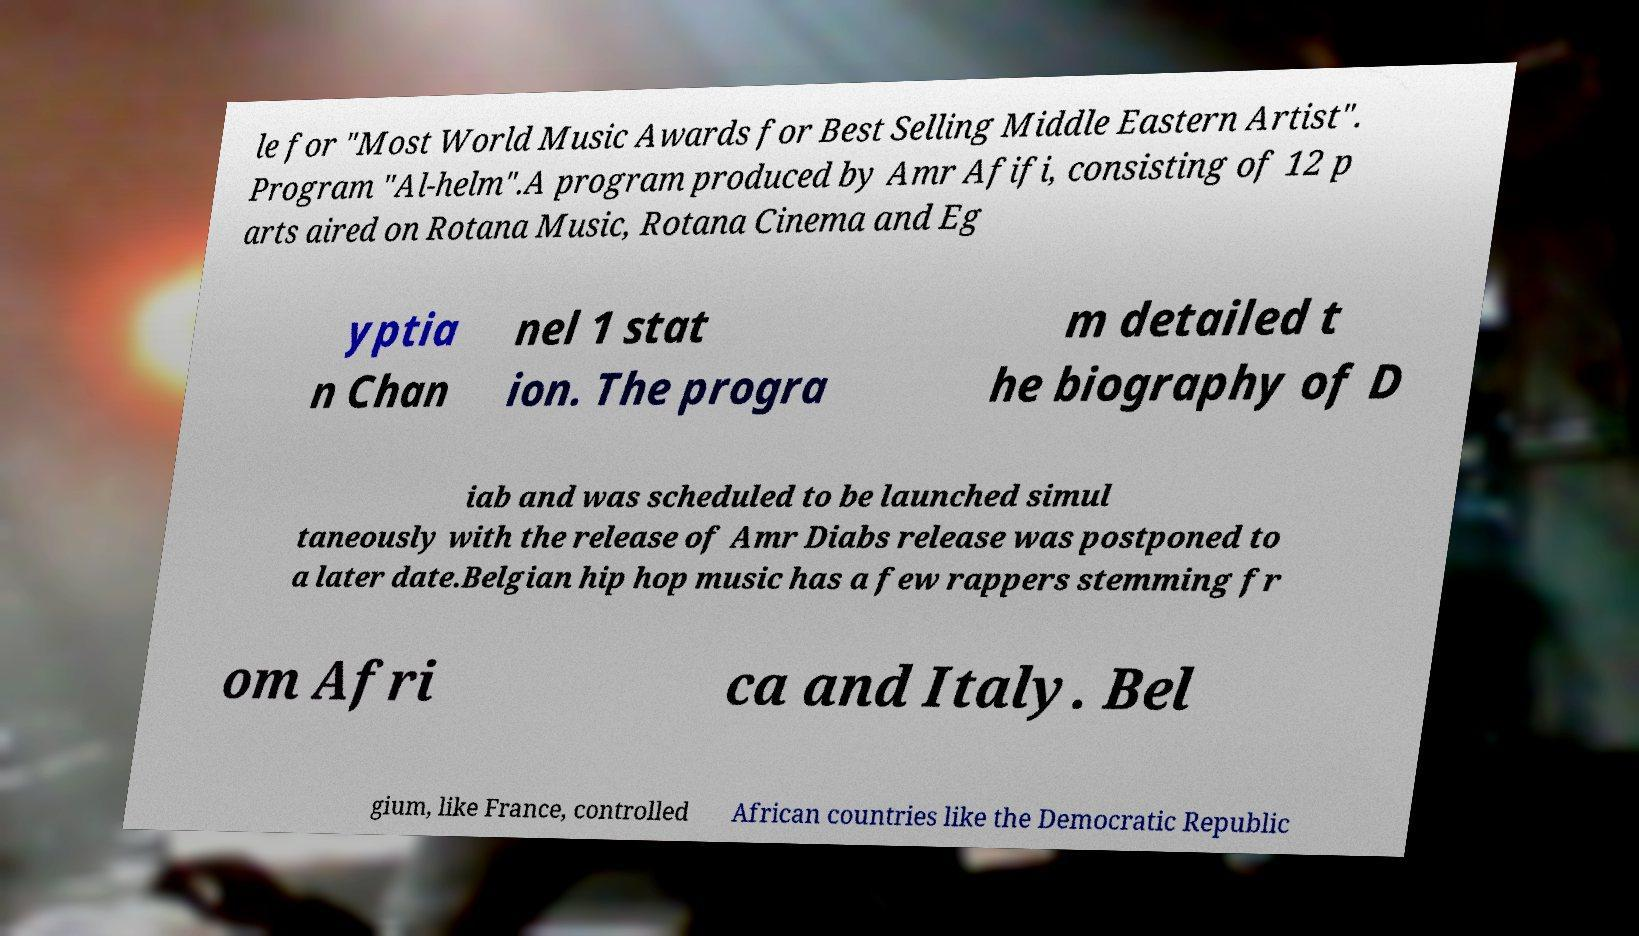Please read and relay the text visible in this image. What does it say? le for "Most World Music Awards for Best Selling Middle Eastern Artist". Program "Al-helm".A program produced by Amr Afifi, consisting of 12 p arts aired on Rotana Music, Rotana Cinema and Eg yptia n Chan nel 1 stat ion. The progra m detailed t he biography of D iab and was scheduled to be launched simul taneously with the release of Amr Diabs release was postponed to a later date.Belgian hip hop music has a few rappers stemming fr om Afri ca and Italy. Bel gium, like France, controlled African countries like the Democratic Republic 